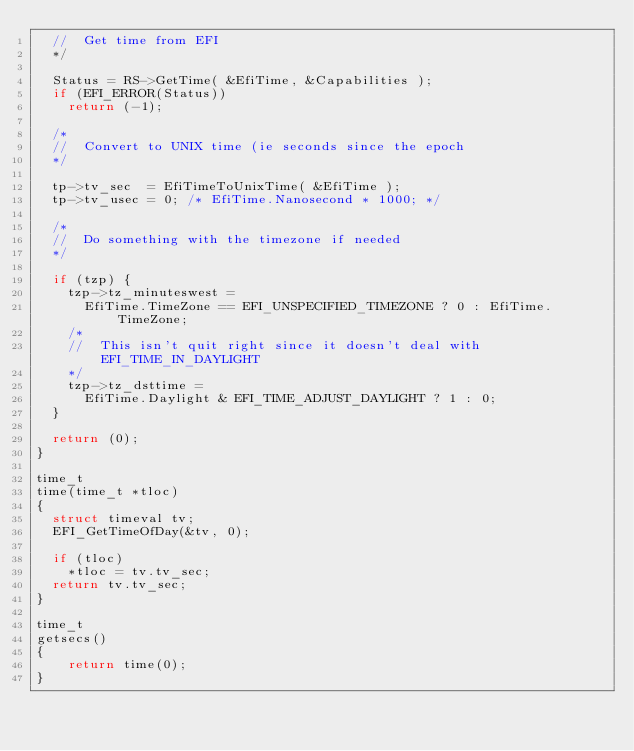Convert code to text. <code><loc_0><loc_0><loc_500><loc_500><_C_>	//  Get time from EFI
	*/

	Status = RS->GetTime( &EfiTime, &Capabilities );
	if (EFI_ERROR(Status))
		return (-1);

	/*
	//  Convert to UNIX time (ie seconds since the epoch
	*/

	tp->tv_sec  = EfiTimeToUnixTime( &EfiTime );
	tp->tv_usec = 0; /* EfiTime.Nanosecond * 1000; */

	/*
	//  Do something with the timezone if needed
	*/

	if (tzp) {
		tzp->tz_minuteswest =
			EfiTime.TimeZone == EFI_UNSPECIFIED_TIMEZONE ? 0 : EfiTime.TimeZone;
		/*
		//  This isn't quit right since it doesn't deal with EFI_TIME_IN_DAYLIGHT
		*/
		tzp->tz_dsttime =
			EfiTime.Daylight & EFI_TIME_ADJUST_DAYLIGHT ? 1 : 0;
	}

	return (0);
}

time_t
time(time_t *tloc)
{
	struct timeval tv;
	EFI_GetTimeOfDay(&tv, 0);
	
	if (tloc)
		*tloc = tv.tv_sec;
	return tv.tv_sec;
}

time_t
getsecs()
{
    return time(0);
}
</code> 